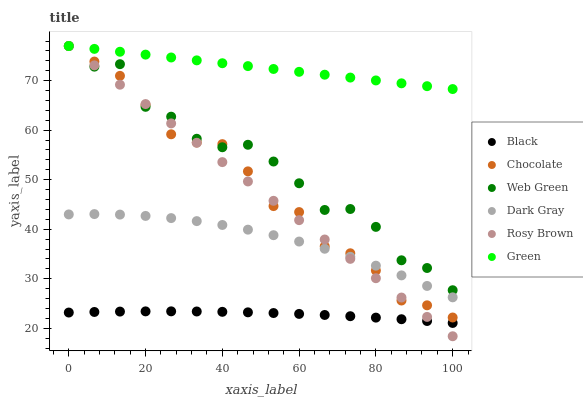Does Black have the minimum area under the curve?
Answer yes or no. Yes. Does Green have the maximum area under the curve?
Answer yes or no. Yes. Does Web Green have the minimum area under the curve?
Answer yes or no. No. Does Web Green have the maximum area under the curve?
Answer yes or no. No. Is Rosy Brown the smoothest?
Answer yes or no. Yes. Is Web Green the roughest?
Answer yes or no. Yes. Is Chocolate the smoothest?
Answer yes or no. No. Is Chocolate the roughest?
Answer yes or no. No. Does Rosy Brown have the lowest value?
Answer yes or no. Yes. Does Web Green have the lowest value?
Answer yes or no. No. Does Green have the highest value?
Answer yes or no. Yes. Does Dark Gray have the highest value?
Answer yes or no. No. Is Black less than Web Green?
Answer yes or no. Yes. Is Dark Gray greater than Black?
Answer yes or no. Yes. Does Chocolate intersect Rosy Brown?
Answer yes or no. Yes. Is Chocolate less than Rosy Brown?
Answer yes or no. No. Is Chocolate greater than Rosy Brown?
Answer yes or no. No. Does Black intersect Web Green?
Answer yes or no. No. 